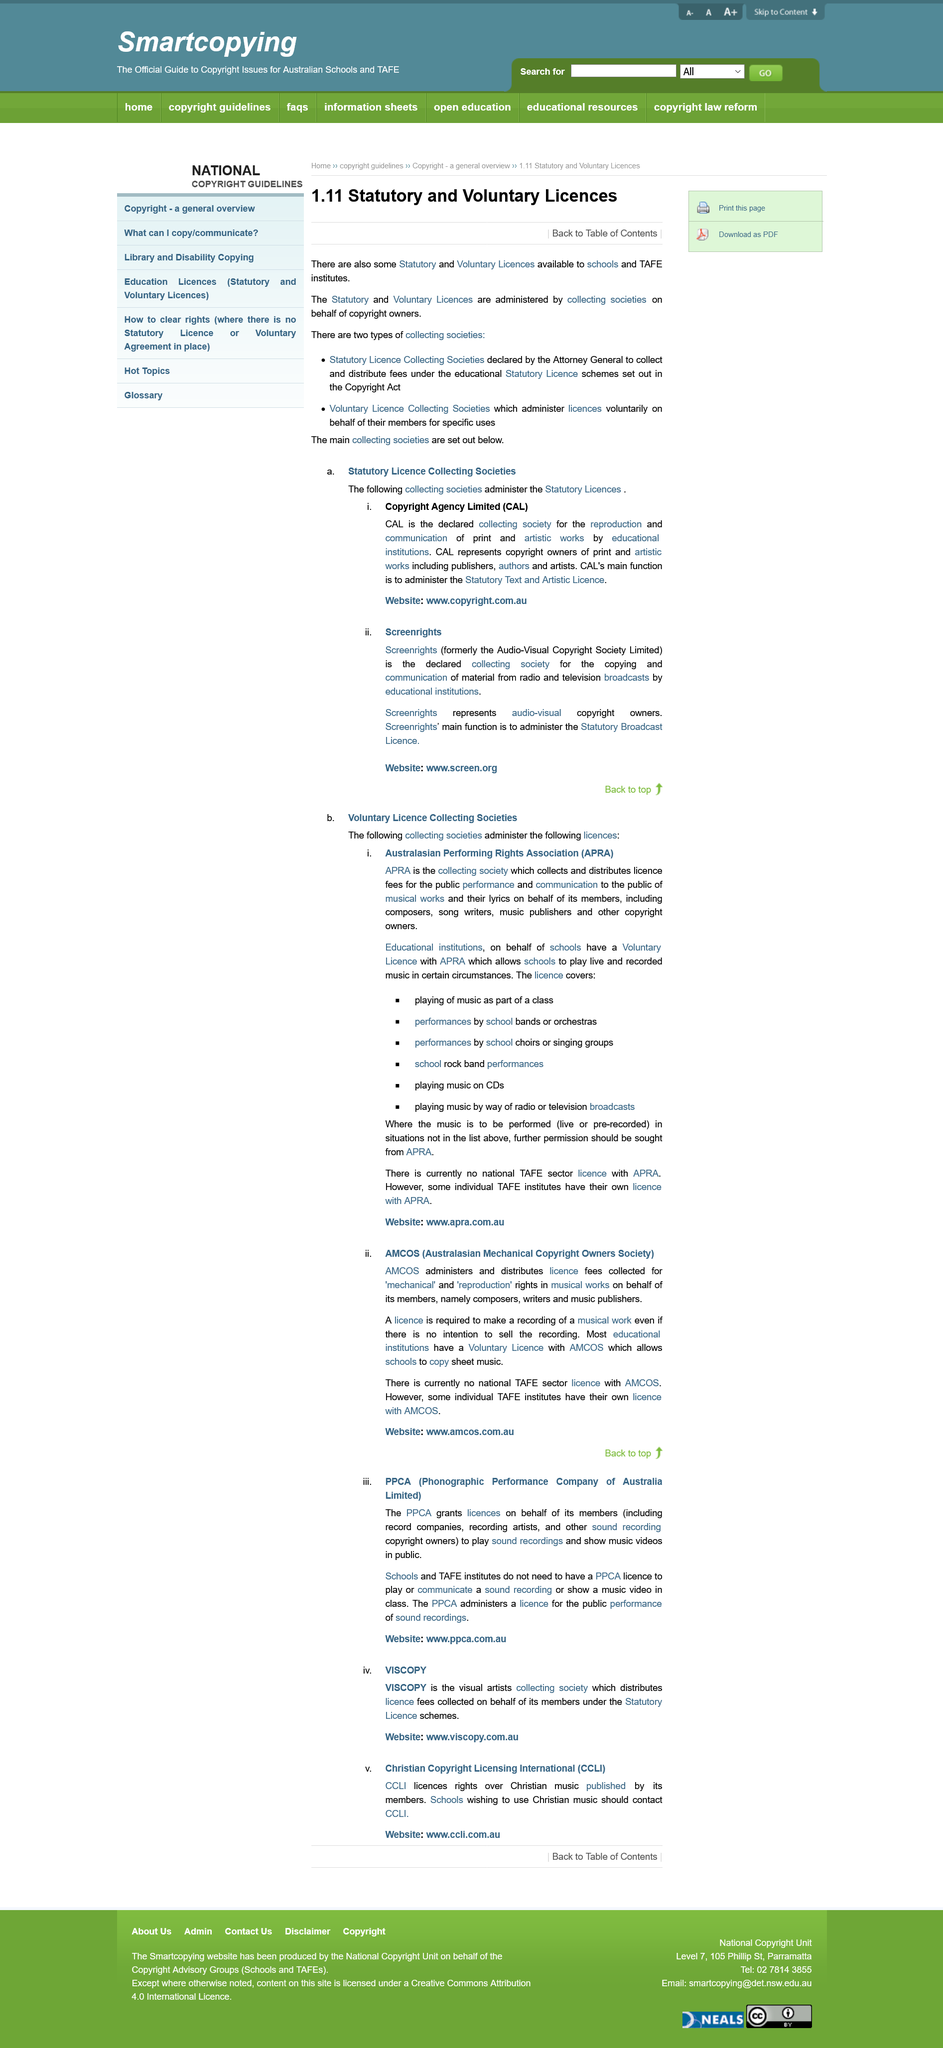Highlight a few significant elements in this photo. Viscopy is an organization that represents visual artists and distributes licensing fees collected on their behalf, under the authority of the statutory Licence Schemes. Yes, Copyright Agency Limited is one of the collecting societies that administers the Statutory Licenses. The acronym AMCOS stands for the Australasian Mechanical Copyright Owners Society, which is an organization dedicated to protecting the rights of those who own the mechanical copyright for musical compositions. There are two types of collecting societies, and they are both used for the purpose of collecting and distributing royalties on behalf of creators. Schools and TAFE Institutions are exempt from needing a PPCA licence to play a music video in class. 